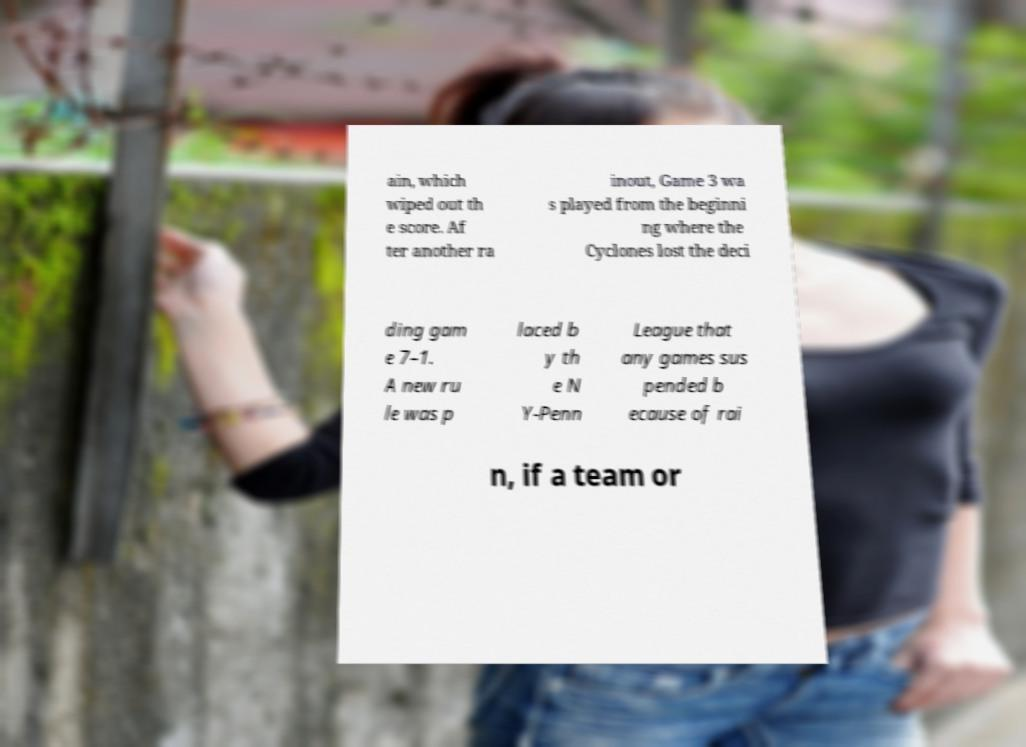Can you accurately transcribe the text from the provided image for me? ain, which wiped out th e score. Af ter another ra inout, Game 3 wa s played from the beginni ng where the Cyclones lost the deci ding gam e 7–1. A new ru le was p laced b y th e N Y-Penn League that any games sus pended b ecause of rai n, if a team or 